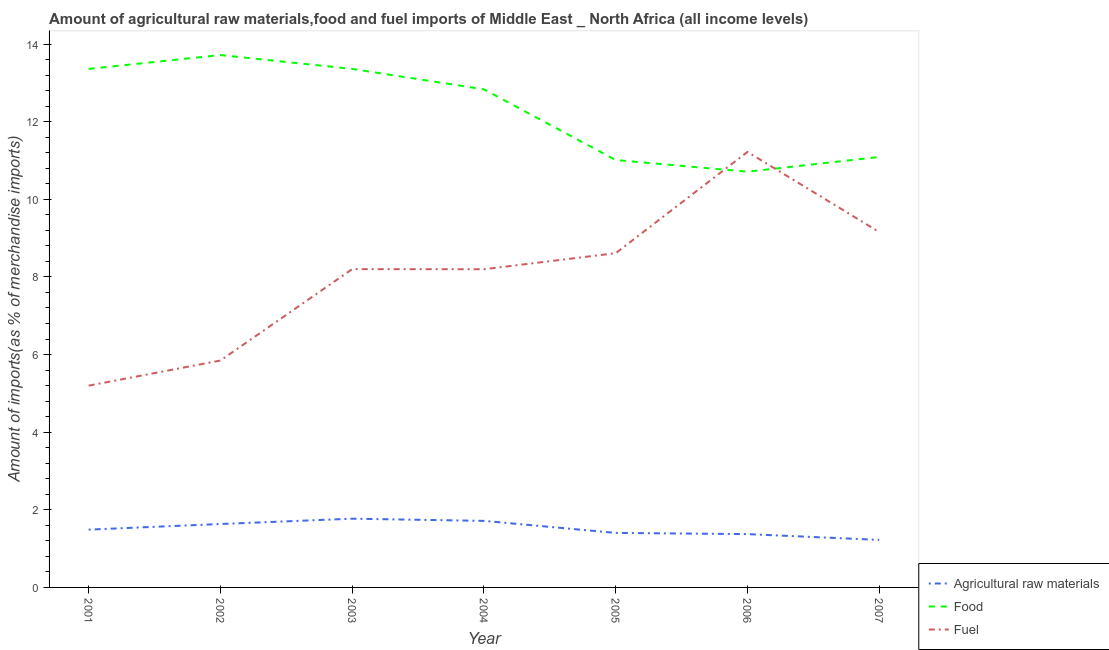What is the percentage of fuel imports in 2002?
Offer a terse response. 5.85. Across all years, what is the maximum percentage of fuel imports?
Provide a short and direct response. 11.22. Across all years, what is the minimum percentage of food imports?
Offer a very short reply. 10.71. In which year was the percentage of fuel imports maximum?
Your answer should be very brief. 2006. What is the total percentage of raw materials imports in the graph?
Provide a succinct answer. 10.61. What is the difference between the percentage of raw materials imports in 2002 and that in 2005?
Provide a short and direct response. 0.23. What is the difference between the percentage of food imports in 2006 and the percentage of raw materials imports in 2005?
Provide a succinct answer. 9.31. What is the average percentage of raw materials imports per year?
Your response must be concise. 1.52. In the year 2004, what is the difference between the percentage of fuel imports and percentage of food imports?
Offer a terse response. -4.64. In how many years, is the percentage of fuel imports greater than 1.2000000000000002 %?
Your answer should be compact. 7. What is the ratio of the percentage of fuel imports in 2006 to that in 2007?
Keep it short and to the point. 1.23. Is the percentage of food imports in 2003 less than that in 2006?
Give a very brief answer. No. What is the difference between the highest and the second highest percentage of fuel imports?
Give a very brief answer. 2.06. What is the difference between the highest and the lowest percentage of food imports?
Provide a succinct answer. 3. Does the percentage of food imports monotonically increase over the years?
Keep it short and to the point. No. Is the percentage of raw materials imports strictly greater than the percentage of food imports over the years?
Give a very brief answer. No. Is the percentage of food imports strictly less than the percentage of raw materials imports over the years?
Give a very brief answer. No. What is the difference between two consecutive major ticks on the Y-axis?
Your answer should be very brief. 2. Does the graph contain grids?
Your response must be concise. No. Where does the legend appear in the graph?
Provide a succinct answer. Bottom right. How are the legend labels stacked?
Offer a very short reply. Vertical. What is the title of the graph?
Your answer should be very brief. Amount of agricultural raw materials,food and fuel imports of Middle East _ North Africa (all income levels). Does "Errors" appear as one of the legend labels in the graph?
Offer a terse response. No. What is the label or title of the Y-axis?
Your answer should be compact. Amount of imports(as % of merchandise imports). What is the Amount of imports(as % of merchandise imports) in Agricultural raw materials in 2001?
Keep it short and to the point. 1.49. What is the Amount of imports(as % of merchandise imports) in Food in 2001?
Give a very brief answer. 13.36. What is the Amount of imports(as % of merchandise imports) of Fuel in 2001?
Keep it short and to the point. 5.2. What is the Amount of imports(as % of merchandise imports) of Agricultural raw materials in 2002?
Provide a succinct answer. 1.63. What is the Amount of imports(as % of merchandise imports) in Food in 2002?
Offer a terse response. 13.72. What is the Amount of imports(as % of merchandise imports) in Fuel in 2002?
Your answer should be compact. 5.85. What is the Amount of imports(as % of merchandise imports) in Agricultural raw materials in 2003?
Your response must be concise. 1.77. What is the Amount of imports(as % of merchandise imports) in Food in 2003?
Offer a very short reply. 13.36. What is the Amount of imports(as % of merchandise imports) in Fuel in 2003?
Offer a very short reply. 8.2. What is the Amount of imports(as % of merchandise imports) in Agricultural raw materials in 2004?
Provide a succinct answer. 1.71. What is the Amount of imports(as % of merchandise imports) of Food in 2004?
Provide a short and direct response. 12.83. What is the Amount of imports(as % of merchandise imports) of Fuel in 2004?
Provide a succinct answer. 8.2. What is the Amount of imports(as % of merchandise imports) in Agricultural raw materials in 2005?
Make the answer very short. 1.4. What is the Amount of imports(as % of merchandise imports) of Food in 2005?
Offer a terse response. 11.01. What is the Amount of imports(as % of merchandise imports) of Fuel in 2005?
Provide a short and direct response. 8.61. What is the Amount of imports(as % of merchandise imports) of Agricultural raw materials in 2006?
Make the answer very short. 1.37. What is the Amount of imports(as % of merchandise imports) in Food in 2006?
Your answer should be very brief. 10.71. What is the Amount of imports(as % of merchandise imports) in Fuel in 2006?
Offer a very short reply. 11.22. What is the Amount of imports(as % of merchandise imports) of Agricultural raw materials in 2007?
Ensure brevity in your answer.  1.22. What is the Amount of imports(as % of merchandise imports) in Food in 2007?
Your answer should be compact. 11.09. What is the Amount of imports(as % of merchandise imports) in Fuel in 2007?
Make the answer very short. 9.16. Across all years, what is the maximum Amount of imports(as % of merchandise imports) in Agricultural raw materials?
Your answer should be very brief. 1.77. Across all years, what is the maximum Amount of imports(as % of merchandise imports) in Food?
Your answer should be very brief. 13.72. Across all years, what is the maximum Amount of imports(as % of merchandise imports) of Fuel?
Provide a short and direct response. 11.22. Across all years, what is the minimum Amount of imports(as % of merchandise imports) in Agricultural raw materials?
Keep it short and to the point. 1.22. Across all years, what is the minimum Amount of imports(as % of merchandise imports) of Food?
Offer a terse response. 10.71. Across all years, what is the minimum Amount of imports(as % of merchandise imports) of Fuel?
Offer a very short reply. 5.2. What is the total Amount of imports(as % of merchandise imports) of Agricultural raw materials in the graph?
Make the answer very short. 10.61. What is the total Amount of imports(as % of merchandise imports) in Food in the graph?
Ensure brevity in your answer.  86.09. What is the total Amount of imports(as % of merchandise imports) of Fuel in the graph?
Provide a short and direct response. 56.44. What is the difference between the Amount of imports(as % of merchandise imports) of Agricultural raw materials in 2001 and that in 2002?
Make the answer very short. -0.15. What is the difference between the Amount of imports(as % of merchandise imports) of Food in 2001 and that in 2002?
Ensure brevity in your answer.  -0.36. What is the difference between the Amount of imports(as % of merchandise imports) in Fuel in 2001 and that in 2002?
Your answer should be compact. -0.65. What is the difference between the Amount of imports(as % of merchandise imports) in Agricultural raw materials in 2001 and that in 2003?
Keep it short and to the point. -0.28. What is the difference between the Amount of imports(as % of merchandise imports) of Fuel in 2001 and that in 2003?
Keep it short and to the point. -3. What is the difference between the Amount of imports(as % of merchandise imports) of Agricultural raw materials in 2001 and that in 2004?
Make the answer very short. -0.23. What is the difference between the Amount of imports(as % of merchandise imports) of Food in 2001 and that in 2004?
Offer a terse response. 0.53. What is the difference between the Amount of imports(as % of merchandise imports) in Fuel in 2001 and that in 2004?
Provide a short and direct response. -3. What is the difference between the Amount of imports(as % of merchandise imports) of Agricultural raw materials in 2001 and that in 2005?
Make the answer very short. 0.08. What is the difference between the Amount of imports(as % of merchandise imports) in Food in 2001 and that in 2005?
Your response must be concise. 2.35. What is the difference between the Amount of imports(as % of merchandise imports) of Fuel in 2001 and that in 2005?
Give a very brief answer. -3.41. What is the difference between the Amount of imports(as % of merchandise imports) of Agricultural raw materials in 2001 and that in 2006?
Provide a short and direct response. 0.12. What is the difference between the Amount of imports(as % of merchandise imports) of Food in 2001 and that in 2006?
Offer a very short reply. 2.65. What is the difference between the Amount of imports(as % of merchandise imports) in Fuel in 2001 and that in 2006?
Keep it short and to the point. -6.02. What is the difference between the Amount of imports(as % of merchandise imports) of Agricultural raw materials in 2001 and that in 2007?
Provide a short and direct response. 0.26. What is the difference between the Amount of imports(as % of merchandise imports) of Food in 2001 and that in 2007?
Your response must be concise. 2.27. What is the difference between the Amount of imports(as % of merchandise imports) in Fuel in 2001 and that in 2007?
Keep it short and to the point. -3.96. What is the difference between the Amount of imports(as % of merchandise imports) of Agricultural raw materials in 2002 and that in 2003?
Your answer should be very brief. -0.14. What is the difference between the Amount of imports(as % of merchandise imports) of Food in 2002 and that in 2003?
Ensure brevity in your answer.  0.36. What is the difference between the Amount of imports(as % of merchandise imports) of Fuel in 2002 and that in 2003?
Your response must be concise. -2.35. What is the difference between the Amount of imports(as % of merchandise imports) of Agricultural raw materials in 2002 and that in 2004?
Provide a succinct answer. -0.08. What is the difference between the Amount of imports(as % of merchandise imports) of Food in 2002 and that in 2004?
Provide a short and direct response. 0.88. What is the difference between the Amount of imports(as % of merchandise imports) in Fuel in 2002 and that in 2004?
Ensure brevity in your answer.  -2.35. What is the difference between the Amount of imports(as % of merchandise imports) in Agricultural raw materials in 2002 and that in 2005?
Your response must be concise. 0.23. What is the difference between the Amount of imports(as % of merchandise imports) of Food in 2002 and that in 2005?
Provide a short and direct response. 2.7. What is the difference between the Amount of imports(as % of merchandise imports) of Fuel in 2002 and that in 2005?
Keep it short and to the point. -2.77. What is the difference between the Amount of imports(as % of merchandise imports) in Agricultural raw materials in 2002 and that in 2006?
Ensure brevity in your answer.  0.26. What is the difference between the Amount of imports(as % of merchandise imports) in Food in 2002 and that in 2006?
Your response must be concise. 3. What is the difference between the Amount of imports(as % of merchandise imports) of Fuel in 2002 and that in 2006?
Ensure brevity in your answer.  -5.37. What is the difference between the Amount of imports(as % of merchandise imports) in Agricultural raw materials in 2002 and that in 2007?
Your response must be concise. 0.41. What is the difference between the Amount of imports(as % of merchandise imports) of Food in 2002 and that in 2007?
Offer a very short reply. 2.63. What is the difference between the Amount of imports(as % of merchandise imports) in Fuel in 2002 and that in 2007?
Give a very brief answer. -3.31. What is the difference between the Amount of imports(as % of merchandise imports) of Agricultural raw materials in 2003 and that in 2004?
Make the answer very short. 0.06. What is the difference between the Amount of imports(as % of merchandise imports) of Food in 2003 and that in 2004?
Keep it short and to the point. 0.53. What is the difference between the Amount of imports(as % of merchandise imports) in Fuel in 2003 and that in 2004?
Offer a terse response. 0. What is the difference between the Amount of imports(as % of merchandise imports) of Agricultural raw materials in 2003 and that in 2005?
Give a very brief answer. 0.37. What is the difference between the Amount of imports(as % of merchandise imports) in Food in 2003 and that in 2005?
Make the answer very short. 2.35. What is the difference between the Amount of imports(as % of merchandise imports) of Fuel in 2003 and that in 2005?
Ensure brevity in your answer.  -0.41. What is the difference between the Amount of imports(as % of merchandise imports) of Agricultural raw materials in 2003 and that in 2006?
Your answer should be compact. 0.4. What is the difference between the Amount of imports(as % of merchandise imports) in Food in 2003 and that in 2006?
Give a very brief answer. 2.65. What is the difference between the Amount of imports(as % of merchandise imports) in Fuel in 2003 and that in 2006?
Make the answer very short. -3.02. What is the difference between the Amount of imports(as % of merchandise imports) of Agricultural raw materials in 2003 and that in 2007?
Give a very brief answer. 0.55. What is the difference between the Amount of imports(as % of merchandise imports) of Food in 2003 and that in 2007?
Keep it short and to the point. 2.27. What is the difference between the Amount of imports(as % of merchandise imports) of Fuel in 2003 and that in 2007?
Ensure brevity in your answer.  -0.96. What is the difference between the Amount of imports(as % of merchandise imports) in Agricultural raw materials in 2004 and that in 2005?
Your response must be concise. 0.31. What is the difference between the Amount of imports(as % of merchandise imports) of Food in 2004 and that in 2005?
Provide a succinct answer. 1.82. What is the difference between the Amount of imports(as % of merchandise imports) in Fuel in 2004 and that in 2005?
Ensure brevity in your answer.  -0.41. What is the difference between the Amount of imports(as % of merchandise imports) in Agricultural raw materials in 2004 and that in 2006?
Make the answer very short. 0.34. What is the difference between the Amount of imports(as % of merchandise imports) of Food in 2004 and that in 2006?
Your answer should be compact. 2.12. What is the difference between the Amount of imports(as % of merchandise imports) of Fuel in 2004 and that in 2006?
Offer a very short reply. -3.02. What is the difference between the Amount of imports(as % of merchandise imports) of Agricultural raw materials in 2004 and that in 2007?
Provide a succinct answer. 0.49. What is the difference between the Amount of imports(as % of merchandise imports) in Food in 2004 and that in 2007?
Offer a very short reply. 1.74. What is the difference between the Amount of imports(as % of merchandise imports) of Fuel in 2004 and that in 2007?
Provide a succinct answer. -0.96. What is the difference between the Amount of imports(as % of merchandise imports) of Agricultural raw materials in 2005 and that in 2006?
Keep it short and to the point. 0.03. What is the difference between the Amount of imports(as % of merchandise imports) in Food in 2005 and that in 2006?
Provide a succinct answer. 0.3. What is the difference between the Amount of imports(as % of merchandise imports) of Fuel in 2005 and that in 2006?
Offer a terse response. -2.61. What is the difference between the Amount of imports(as % of merchandise imports) of Agricultural raw materials in 2005 and that in 2007?
Ensure brevity in your answer.  0.18. What is the difference between the Amount of imports(as % of merchandise imports) in Food in 2005 and that in 2007?
Your response must be concise. -0.08. What is the difference between the Amount of imports(as % of merchandise imports) in Fuel in 2005 and that in 2007?
Your response must be concise. -0.54. What is the difference between the Amount of imports(as % of merchandise imports) in Agricultural raw materials in 2006 and that in 2007?
Ensure brevity in your answer.  0.15. What is the difference between the Amount of imports(as % of merchandise imports) in Food in 2006 and that in 2007?
Offer a very short reply. -0.38. What is the difference between the Amount of imports(as % of merchandise imports) in Fuel in 2006 and that in 2007?
Make the answer very short. 2.06. What is the difference between the Amount of imports(as % of merchandise imports) of Agricultural raw materials in 2001 and the Amount of imports(as % of merchandise imports) of Food in 2002?
Your answer should be compact. -12.23. What is the difference between the Amount of imports(as % of merchandise imports) in Agricultural raw materials in 2001 and the Amount of imports(as % of merchandise imports) in Fuel in 2002?
Make the answer very short. -4.36. What is the difference between the Amount of imports(as % of merchandise imports) in Food in 2001 and the Amount of imports(as % of merchandise imports) in Fuel in 2002?
Provide a succinct answer. 7.51. What is the difference between the Amount of imports(as % of merchandise imports) in Agricultural raw materials in 2001 and the Amount of imports(as % of merchandise imports) in Food in 2003?
Ensure brevity in your answer.  -11.87. What is the difference between the Amount of imports(as % of merchandise imports) in Agricultural raw materials in 2001 and the Amount of imports(as % of merchandise imports) in Fuel in 2003?
Your answer should be compact. -6.71. What is the difference between the Amount of imports(as % of merchandise imports) in Food in 2001 and the Amount of imports(as % of merchandise imports) in Fuel in 2003?
Your answer should be very brief. 5.16. What is the difference between the Amount of imports(as % of merchandise imports) of Agricultural raw materials in 2001 and the Amount of imports(as % of merchandise imports) of Food in 2004?
Your answer should be compact. -11.34. What is the difference between the Amount of imports(as % of merchandise imports) in Agricultural raw materials in 2001 and the Amount of imports(as % of merchandise imports) in Fuel in 2004?
Make the answer very short. -6.71. What is the difference between the Amount of imports(as % of merchandise imports) of Food in 2001 and the Amount of imports(as % of merchandise imports) of Fuel in 2004?
Give a very brief answer. 5.16. What is the difference between the Amount of imports(as % of merchandise imports) of Agricultural raw materials in 2001 and the Amount of imports(as % of merchandise imports) of Food in 2005?
Give a very brief answer. -9.52. What is the difference between the Amount of imports(as % of merchandise imports) of Agricultural raw materials in 2001 and the Amount of imports(as % of merchandise imports) of Fuel in 2005?
Provide a succinct answer. -7.12. What is the difference between the Amount of imports(as % of merchandise imports) of Food in 2001 and the Amount of imports(as % of merchandise imports) of Fuel in 2005?
Offer a terse response. 4.75. What is the difference between the Amount of imports(as % of merchandise imports) of Agricultural raw materials in 2001 and the Amount of imports(as % of merchandise imports) of Food in 2006?
Offer a terse response. -9.22. What is the difference between the Amount of imports(as % of merchandise imports) in Agricultural raw materials in 2001 and the Amount of imports(as % of merchandise imports) in Fuel in 2006?
Make the answer very short. -9.73. What is the difference between the Amount of imports(as % of merchandise imports) in Food in 2001 and the Amount of imports(as % of merchandise imports) in Fuel in 2006?
Offer a terse response. 2.14. What is the difference between the Amount of imports(as % of merchandise imports) in Agricultural raw materials in 2001 and the Amount of imports(as % of merchandise imports) in Food in 2007?
Your answer should be compact. -9.6. What is the difference between the Amount of imports(as % of merchandise imports) in Agricultural raw materials in 2001 and the Amount of imports(as % of merchandise imports) in Fuel in 2007?
Your response must be concise. -7.67. What is the difference between the Amount of imports(as % of merchandise imports) in Food in 2001 and the Amount of imports(as % of merchandise imports) in Fuel in 2007?
Ensure brevity in your answer.  4.2. What is the difference between the Amount of imports(as % of merchandise imports) in Agricultural raw materials in 2002 and the Amount of imports(as % of merchandise imports) in Food in 2003?
Your answer should be compact. -11.73. What is the difference between the Amount of imports(as % of merchandise imports) of Agricultural raw materials in 2002 and the Amount of imports(as % of merchandise imports) of Fuel in 2003?
Offer a terse response. -6.57. What is the difference between the Amount of imports(as % of merchandise imports) in Food in 2002 and the Amount of imports(as % of merchandise imports) in Fuel in 2003?
Offer a terse response. 5.52. What is the difference between the Amount of imports(as % of merchandise imports) in Agricultural raw materials in 2002 and the Amount of imports(as % of merchandise imports) in Food in 2004?
Offer a very short reply. -11.2. What is the difference between the Amount of imports(as % of merchandise imports) of Agricultural raw materials in 2002 and the Amount of imports(as % of merchandise imports) of Fuel in 2004?
Provide a short and direct response. -6.56. What is the difference between the Amount of imports(as % of merchandise imports) in Food in 2002 and the Amount of imports(as % of merchandise imports) in Fuel in 2004?
Offer a very short reply. 5.52. What is the difference between the Amount of imports(as % of merchandise imports) of Agricultural raw materials in 2002 and the Amount of imports(as % of merchandise imports) of Food in 2005?
Offer a terse response. -9.38. What is the difference between the Amount of imports(as % of merchandise imports) of Agricultural raw materials in 2002 and the Amount of imports(as % of merchandise imports) of Fuel in 2005?
Your response must be concise. -6.98. What is the difference between the Amount of imports(as % of merchandise imports) in Food in 2002 and the Amount of imports(as % of merchandise imports) in Fuel in 2005?
Give a very brief answer. 5.1. What is the difference between the Amount of imports(as % of merchandise imports) in Agricultural raw materials in 2002 and the Amount of imports(as % of merchandise imports) in Food in 2006?
Provide a succinct answer. -9.08. What is the difference between the Amount of imports(as % of merchandise imports) of Agricultural raw materials in 2002 and the Amount of imports(as % of merchandise imports) of Fuel in 2006?
Provide a succinct answer. -9.59. What is the difference between the Amount of imports(as % of merchandise imports) of Food in 2002 and the Amount of imports(as % of merchandise imports) of Fuel in 2006?
Your answer should be very brief. 2.5. What is the difference between the Amount of imports(as % of merchandise imports) in Agricultural raw materials in 2002 and the Amount of imports(as % of merchandise imports) in Food in 2007?
Give a very brief answer. -9.46. What is the difference between the Amount of imports(as % of merchandise imports) in Agricultural raw materials in 2002 and the Amount of imports(as % of merchandise imports) in Fuel in 2007?
Keep it short and to the point. -7.52. What is the difference between the Amount of imports(as % of merchandise imports) of Food in 2002 and the Amount of imports(as % of merchandise imports) of Fuel in 2007?
Keep it short and to the point. 4.56. What is the difference between the Amount of imports(as % of merchandise imports) in Agricultural raw materials in 2003 and the Amount of imports(as % of merchandise imports) in Food in 2004?
Your answer should be very brief. -11.06. What is the difference between the Amount of imports(as % of merchandise imports) in Agricultural raw materials in 2003 and the Amount of imports(as % of merchandise imports) in Fuel in 2004?
Offer a very short reply. -6.43. What is the difference between the Amount of imports(as % of merchandise imports) of Food in 2003 and the Amount of imports(as % of merchandise imports) of Fuel in 2004?
Make the answer very short. 5.16. What is the difference between the Amount of imports(as % of merchandise imports) of Agricultural raw materials in 2003 and the Amount of imports(as % of merchandise imports) of Food in 2005?
Provide a succinct answer. -9.24. What is the difference between the Amount of imports(as % of merchandise imports) in Agricultural raw materials in 2003 and the Amount of imports(as % of merchandise imports) in Fuel in 2005?
Keep it short and to the point. -6.84. What is the difference between the Amount of imports(as % of merchandise imports) in Food in 2003 and the Amount of imports(as % of merchandise imports) in Fuel in 2005?
Offer a very short reply. 4.75. What is the difference between the Amount of imports(as % of merchandise imports) in Agricultural raw materials in 2003 and the Amount of imports(as % of merchandise imports) in Food in 2006?
Provide a succinct answer. -8.94. What is the difference between the Amount of imports(as % of merchandise imports) in Agricultural raw materials in 2003 and the Amount of imports(as % of merchandise imports) in Fuel in 2006?
Provide a short and direct response. -9.45. What is the difference between the Amount of imports(as % of merchandise imports) of Food in 2003 and the Amount of imports(as % of merchandise imports) of Fuel in 2006?
Your answer should be very brief. 2.14. What is the difference between the Amount of imports(as % of merchandise imports) of Agricultural raw materials in 2003 and the Amount of imports(as % of merchandise imports) of Food in 2007?
Offer a very short reply. -9.32. What is the difference between the Amount of imports(as % of merchandise imports) in Agricultural raw materials in 2003 and the Amount of imports(as % of merchandise imports) in Fuel in 2007?
Your answer should be compact. -7.39. What is the difference between the Amount of imports(as % of merchandise imports) in Food in 2003 and the Amount of imports(as % of merchandise imports) in Fuel in 2007?
Provide a succinct answer. 4.2. What is the difference between the Amount of imports(as % of merchandise imports) of Agricultural raw materials in 2004 and the Amount of imports(as % of merchandise imports) of Food in 2005?
Your answer should be compact. -9.3. What is the difference between the Amount of imports(as % of merchandise imports) in Agricultural raw materials in 2004 and the Amount of imports(as % of merchandise imports) in Fuel in 2005?
Your answer should be compact. -6.9. What is the difference between the Amount of imports(as % of merchandise imports) of Food in 2004 and the Amount of imports(as % of merchandise imports) of Fuel in 2005?
Provide a succinct answer. 4.22. What is the difference between the Amount of imports(as % of merchandise imports) of Agricultural raw materials in 2004 and the Amount of imports(as % of merchandise imports) of Food in 2006?
Your answer should be very brief. -9. What is the difference between the Amount of imports(as % of merchandise imports) in Agricultural raw materials in 2004 and the Amount of imports(as % of merchandise imports) in Fuel in 2006?
Ensure brevity in your answer.  -9.51. What is the difference between the Amount of imports(as % of merchandise imports) in Food in 2004 and the Amount of imports(as % of merchandise imports) in Fuel in 2006?
Provide a short and direct response. 1.61. What is the difference between the Amount of imports(as % of merchandise imports) of Agricultural raw materials in 2004 and the Amount of imports(as % of merchandise imports) of Food in 2007?
Provide a short and direct response. -9.38. What is the difference between the Amount of imports(as % of merchandise imports) of Agricultural raw materials in 2004 and the Amount of imports(as % of merchandise imports) of Fuel in 2007?
Offer a terse response. -7.44. What is the difference between the Amount of imports(as % of merchandise imports) of Food in 2004 and the Amount of imports(as % of merchandise imports) of Fuel in 2007?
Offer a very short reply. 3.68. What is the difference between the Amount of imports(as % of merchandise imports) of Agricultural raw materials in 2005 and the Amount of imports(as % of merchandise imports) of Food in 2006?
Your answer should be very brief. -9.31. What is the difference between the Amount of imports(as % of merchandise imports) in Agricultural raw materials in 2005 and the Amount of imports(as % of merchandise imports) in Fuel in 2006?
Keep it short and to the point. -9.82. What is the difference between the Amount of imports(as % of merchandise imports) in Food in 2005 and the Amount of imports(as % of merchandise imports) in Fuel in 2006?
Provide a short and direct response. -0.21. What is the difference between the Amount of imports(as % of merchandise imports) in Agricultural raw materials in 2005 and the Amount of imports(as % of merchandise imports) in Food in 2007?
Your answer should be compact. -9.69. What is the difference between the Amount of imports(as % of merchandise imports) of Agricultural raw materials in 2005 and the Amount of imports(as % of merchandise imports) of Fuel in 2007?
Your answer should be very brief. -7.75. What is the difference between the Amount of imports(as % of merchandise imports) of Food in 2005 and the Amount of imports(as % of merchandise imports) of Fuel in 2007?
Provide a succinct answer. 1.86. What is the difference between the Amount of imports(as % of merchandise imports) of Agricultural raw materials in 2006 and the Amount of imports(as % of merchandise imports) of Food in 2007?
Offer a very short reply. -9.72. What is the difference between the Amount of imports(as % of merchandise imports) in Agricultural raw materials in 2006 and the Amount of imports(as % of merchandise imports) in Fuel in 2007?
Give a very brief answer. -7.78. What is the difference between the Amount of imports(as % of merchandise imports) in Food in 2006 and the Amount of imports(as % of merchandise imports) in Fuel in 2007?
Give a very brief answer. 1.56. What is the average Amount of imports(as % of merchandise imports) of Agricultural raw materials per year?
Provide a succinct answer. 1.52. What is the average Amount of imports(as % of merchandise imports) in Food per year?
Provide a succinct answer. 12.3. What is the average Amount of imports(as % of merchandise imports) in Fuel per year?
Your answer should be compact. 8.06. In the year 2001, what is the difference between the Amount of imports(as % of merchandise imports) of Agricultural raw materials and Amount of imports(as % of merchandise imports) of Food?
Make the answer very short. -11.87. In the year 2001, what is the difference between the Amount of imports(as % of merchandise imports) of Agricultural raw materials and Amount of imports(as % of merchandise imports) of Fuel?
Provide a succinct answer. -3.71. In the year 2001, what is the difference between the Amount of imports(as % of merchandise imports) of Food and Amount of imports(as % of merchandise imports) of Fuel?
Ensure brevity in your answer.  8.16. In the year 2002, what is the difference between the Amount of imports(as % of merchandise imports) in Agricultural raw materials and Amount of imports(as % of merchandise imports) in Food?
Offer a terse response. -12.08. In the year 2002, what is the difference between the Amount of imports(as % of merchandise imports) of Agricultural raw materials and Amount of imports(as % of merchandise imports) of Fuel?
Make the answer very short. -4.21. In the year 2002, what is the difference between the Amount of imports(as % of merchandise imports) of Food and Amount of imports(as % of merchandise imports) of Fuel?
Give a very brief answer. 7.87. In the year 2003, what is the difference between the Amount of imports(as % of merchandise imports) in Agricultural raw materials and Amount of imports(as % of merchandise imports) in Food?
Give a very brief answer. -11.59. In the year 2003, what is the difference between the Amount of imports(as % of merchandise imports) of Agricultural raw materials and Amount of imports(as % of merchandise imports) of Fuel?
Make the answer very short. -6.43. In the year 2003, what is the difference between the Amount of imports(as % of merchandise imports) of Food and Amount of imports(as % of merchandise imports) of Fuel?
Your response must be concise. 5.16. In the year 2004, what is the difference between the Amount of imports(as % of merchandise imports) in Agricultural raw materials and Amount of imports(as % of merchandise imports) in Food?
Your response must be concise. -11.12. In the year 2004, what is the difference between the Amount of imports(as % of merchandise imports) in Agricultural raw materials and Amount of imports(as % of merchandise imports) in Fuel?
Provide a short and direct response. -6.48. In the year 2004, what is the difference between the Amount of imports(as % of merchandise imports) in Food and Amount of imports(as % of merchandise imports) in Fuel?
Ensure brevity in your answer.  4.63. In the year 2005, what is the difference between the Amount of imports(as % of merchandise imports) in Agricultural raw materials and Amount of imports(as % of merchandise imports) in Food?
Offer a very short reply. -9.61. In the year 2005, what is the difference between the Amount of imports(as % of merchandise imports) of Agricultural raw materials and Amount of imports(as % of merchandise imports) of Fuel?
Make the answer very short. -7.21. In the year 2005, what is the difference between the Amount of imports(as % of merchandise imports) of Food and Amount of imports(as % of merchandise imports) of Fuel?
Provide a succinct answer. 2.4. In the year 2006, what is the difference between the Amount of imports(as % of merchandise imports) of Agricultural raw materials and Amount of imports(as % of merchandise imports) of Food?
Offer a terse response. -9.34. In the year 2006, what is the difference between the Amount of imports(as % of merchandise imports) in Agricultural raw materials and Amount of imports(as % of merchandise imports) in Fuel?
Offer a terse response. -9.85. In the year 2006, what is the difference between the Amount of imports(as % of merchandise imports) in Food and Amount of imports(as % of merchandise imports) in Fuel?
Your response must be concise. -0.51. In the year 2007, what is the difference between the Amount of imports(as % of merchandise imports) of Agricultural raw materials and Amount of imports(as % of merchandise imports) of Food?
Provide a succinct answer. -9.87. In the year 2007, what is the difference between the Amount of imports(as % of merchandise imports) in Agricultural raw materials and Amount of imports(as % of merchandise imports) in Fuel?
Keep it short and to the point. -7.93. In the year 2007, what is the difference between the Amount of imports(as % of merchandise imports) in Food and Amount of imports(as % of merchandise imports) in Fuel?
Provide a succinct answer. 1.93. What is the ratio of the Amount of imports(as % of merchandise imports) in Agricultural raw materials in 2001 to that in 2002?
Give a very brief answer. 0.91. What is the ratio of the Amount of imports(as % of merchandise imports) in Food in 2001 to that in 2002?
Your answer should be compact. 0.97. What is the ratio of the Amount of imports(as % of merchandise imports) in Fuel in 2001 to that in 2002?
Keep it short and to the point. 0.89. What is the ratio of the Amount of imports(as % of merchandise imports) of Agricultural raw materials in 2001 to that in 2003?
Offer a very short reply. 0.84. What is the ratio of the Amount of imports(as % of merchandise imports) in Fuel in 2001 to that in 2003?
Provide a succinct answer. 0.63. What is the ratio of the Amount of imports(as % of merchandise imports) of Agricultural raw materials in 2001 to that in 2004?
Your answer should be very brief. 0.87. What is the ratio of the Amount of imports(as % of merchandise imports) in Food in 2001 to that in 2004?
Provide a succinct answer. 1.04. What is the ratio of the Amount of imports(as % of merchandise imports) in Fuel in 2001 to that in 2004?
Your response must be concise. 0.63. What is the ratio of the Amount of imports(as % of merchandise imports) of Agricultural raw materials in 2001 to that in 2005?
Your answer should be compact. 1.06. What is the ratio of the Amount of imports(as % of merchandise imports) in Food in 2001 to that in 2005?
Provide a short and direct response. 1.21. What is the ratio of the Amount of imports(as % of merchandise imports) in Fuel in 2001 to that in 2005?
Provide a short and direct response. 0.6. What is the ratio of the Amount of imports(as % of merchandise imports) in Agricultural raw materials in 2001 to that in 2006?
Your answer should be compact. 1.08. What is the ratio of the Amount of imports(as % of merchandise imports) in Food in 2001 to that in 2006?
Give a very brief answer. 1.25. What is the ratio of the Amount of imports(as % of merchandise imports) in Fuel in 2001 to that in 2006?
Offer a terse response. 0.46. What is the ratio of the Amount of imports(as % of merchandise imports) in Agricultural raw materials in 2001 to that in 2007?
Your answer should be very brief. 1.22. What is the ratio of the Amount of imports(as % of merchandise imports) in Food in 2001 to that in 2007?
Offer a terse response. 1.2. What is the ratio of the Amount of imports(as % of merchandise imports) in Fuel in 2001 to that in 2007?
Offer a terse response. 0.57. What is the ratio of the Amount of imports(as % of merchandise imports) in Agricultural raw materials in 2002 to that in 2003?
Ensure brevity in your answer.  0.92. What is the ratio of the Amount of imports(as % of merchandise imports) of Food in 2002 to that in 2003?
Your answer should be very brief. 1.03. What is the ratio of the Amount of imports(as % of merchandise imports) in Fuel in 2002 to that in 2003?
Make the answer very short. 0.71. What is the ratio of the Amount of imports(as % of merchandise imports) in Agricultural raw materials in 2002 to that in 2004?
Your answer should be compact. 0.95. What is the ratio of the Amount of imports(as % of merchandise imports) in Food in 2002 to that in 2004?
Your answer should be compact. 1.07. What is the ratio of the Amount of imports(as % of merchandise imports) of Fuel in 2002 to that in 2004?
Keep it short and to the point. 0.71. What is the ratio of the Amount of imports(as % of merchandise imports) of Agricultural raw materials in 2002 to that in 2005?
Give a very brief answer. 1.16. What is the ratio of the Amount of imports(as % of merchandise imports) of Food in 2002 to that in 2005?
Make the answer very short. 1.25. What is the ratio of the Amount of imports(as % of merchandise imports) of Fuel in 2002 to that in 2005?
Provide a succinct answer. 0.68. What is the ratio of the Amount of imports(as % of merchandise imports) of Agricultural raw materials in 2002 to that in 2006?
Provide a succinct answer. 1.19. What is the ratio of the Amount of imports(as % of merchandise imports) in Food in 2002 to that in 2006?
Offer a very short reply. 1.28. What is the ratio of the Amount of imports(as % of merchandise imports) in Fuel in 2002 to that in 2006?
Keep it short and to the point. 0.52. What is the ratio of the Amount of imports(as % of merchandise imports) in Agricultural raw materials in 2002 to that in 2007?
Give a very brief answer. 1.33. What is the ratio of the Amount of imports(as % of merchandise imports) in Food in 2002 to that in 2007?
Offer a terse response. 1.24. What is the ratio of the Amount of imports(as % of merchandise imports) in Fuel in 2002 to that in 2007?
Give a very brief answer. 0.64. What is the ratio of the Amount of imports(as % of merchandise imports) of Agricultural raw materials in 2003 to that in 2004?
Your response must be concise. 1.03. What is the ratio of the Amount of imports(as % of merchandise imports) of Food in 2003 to that in 2004?
Make the answer very short. 1.04. What is the ratio of the Amount of imports(as % of merchandise imports) of Agricultural raw materials in 2003 to that in 2005?
Make the answer very short. 1.26. What is the ratio of the Amount of imports(as % of merchandise imports) in Food in 2003 to that in 2005?
Offer a very short reply. 1.21. What is the ratio of the Amount of imports(as % of merchandise imports) of Fuel in 2003 to that in 2005?
Offer a very short reply. 0.95. What is the ratio of the Amount of imports(as % of merchandise imports) in Agricultural raw materials in 2003 to that in 2006?
Your answer should be compact. 1.29. What is the ratio of the Amount of imports(as % of merchandise imports) in Food in 2003 to that in 2006?
Offer a terse response. 1.25. What is the ratio of the Amount of imports(as % of merchandise imports) in Fuel in 2003 to that in 2006?
Offer a very short reply. 0.73. What is the ratio of the Amount of imports(as % of merchandise imports) of Agricultural raw materials in 2003 to that in 2007?
Ensure brevity in your answer.  1.45. What is the ratio of the Amount of imports(as % of merchandise imports) in Food in 2003 to that in 2007?
Ensure brevity in your answer.  1.2. What is the ratio of the Amount of imports(as % of merchandise imports) of Fuel in 2003 to that in 2007?
Give a very brief answer. 0.9. What is the ratio of the Amount of imports(as % of merchandise imports) in Agricultural raw materials in 2004 to that in 2005?
Offer a very short reply. 1.22. What is the ratio of the Amount of imports(as % of merchandise imports) of Food in 2004 to that in 2005?
Your answer should be very brief. 1.17. What is the ratio of the Amount of imports(as % of merchandise imports) in Fuel in 2004 to that in 2005?
Provide a short and direct response. 0.95. What is the ratio of the Amount of imports(as % of merchandise imports) in Agricultural raw materials in 2004 to that in 2006?
Make the answer very short. 1.25. What is the ratio of the Amount of imports(as % of merchandise imports) of Food in 2004 to that in 2006?
Offer a terse response. 1.2. What is the ratio of the Amount of imports(as % of merchandise imports) of Fuel in 2004 to that in 2006?
Keep it short and to the point. 0.73. What is the ratio of the Amount of imports(as % of merchandise imports) of Agricultural raw materials in 2004 to that in 2007?
Your response must be concise. 1.4. What is the ratio of the Amount of imports(as % of merchandise imports) in Food in 2004 to that in 2007?
Give a very brief answer. 1.16. What is the ratio of the Amount of imports(as % of merchandise imports) of Fuel in 2004 to that in 2007?
Give a very brief answer. 0.9. What is the ratio of the Amount of imports(as % of merchandise imports) of Agricultural raw materials in 2005 to that in 2006?
Your answer should be compact. 1.02. What is the ratio of the Amount of imports(as % of merchandise imports) in Food in 2005 to that in 2006?
Make the answer very short. 1.03. What is the ratio of the Amount of imports(as % of merchandise imports) in Fuel in 2005 to that in 2006?
Offer a terse response. 0.77. What is the ratio of the Amount of imports(as % of merchandise imports) of Agricultural raw materials in 2005 to that in 2007?
Keep it short and to the point. 1.15. What is the ratio of the Amount of imports(as % of merchandise imports) in Fuel in 2005 to that in 2007?
Make the answer very short. 0.94. What is the ratio of the Amount of imports(as % of merchandise imports) of Agricultural raw materials in 2006 to that in 2007?
Your answer should be compact. 1.12. What is the ratio of the Amount of imports(as % of merchandise imports) in Food in 2006 to that in 2007?
Your answer should be compact. 0.97. What is the ratio of the Amount of imports(as % of merchandise imports) of Fuel in 2006 to that in 2007?
Keep it short and to the point. 1.23. What is the difference between the highest and the second highest Amount of imports(as % of merchandise imports) in Agricultural raw materials?
Keep it short and to the point. 0.06. What is the difference between the highest and the second highest Amount of imports(as % of merchandise imports) in Food?
Your answer should be very brief. 0.36. What is the difference between the highest and the second highest Amount of imports(as % of merchandise imports) of Fuel?
Make the answer very short. 2.06. What is the difference between the highest and the lowest Amount of imports(as % of merchandise imports) in Agricultural raw materials?
Offer a terse response. 0.55. What is the difference between the highest and the lowest Amount of imports(as % of merchandise imports) of Food?
Keep it short and to the point. 3. What is the difference between the highest and the lowest Amount of imports(as % of merchandise imports) in Fuel?
Your response must be concise. 6.02. 